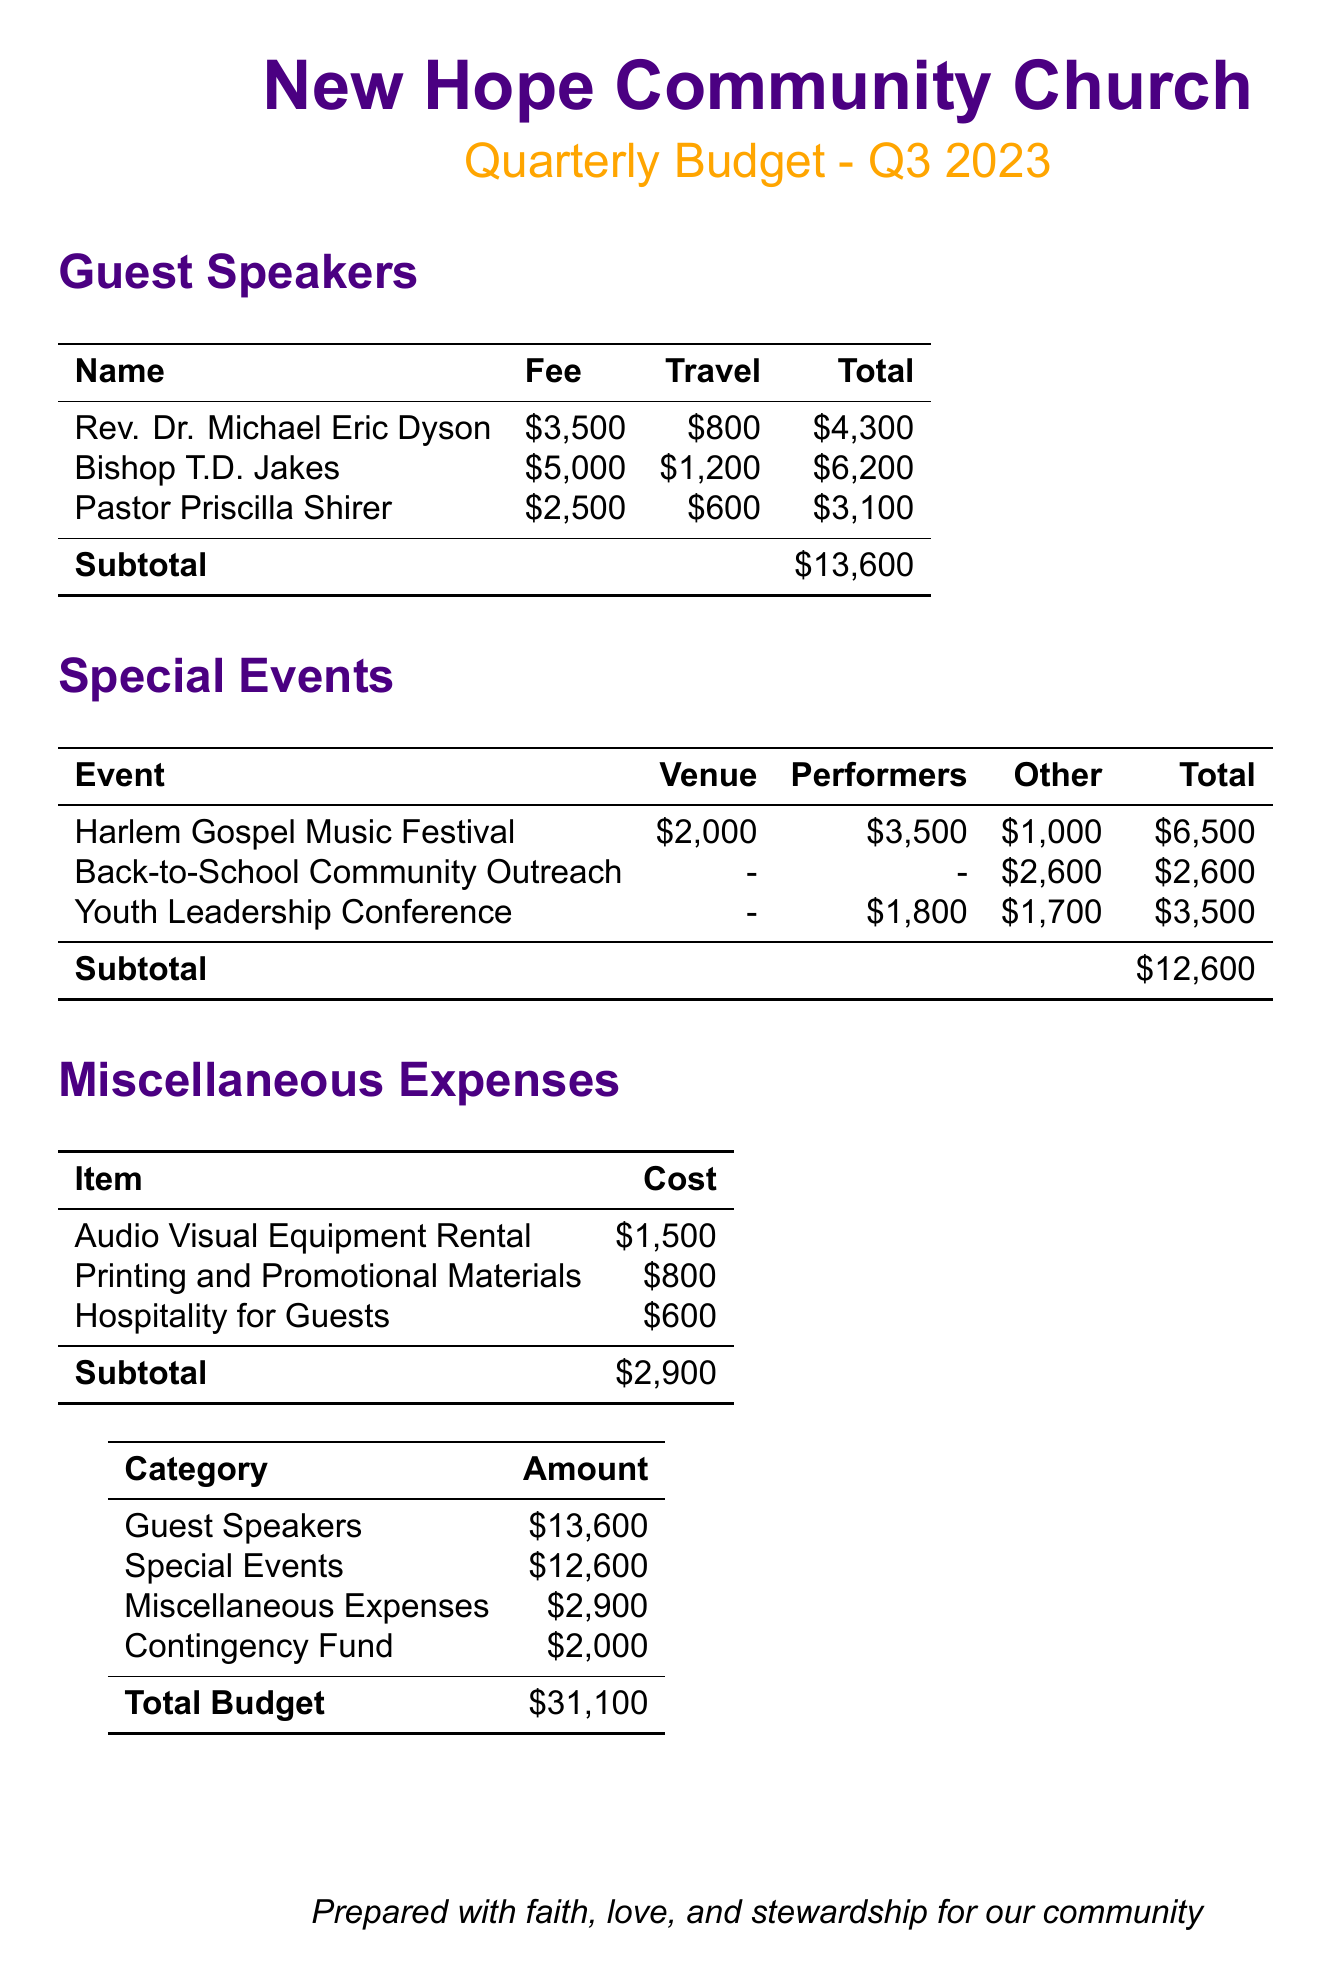What is the total cost for guest speakers? The total cost for guest speakers can be found in the budget section and is listed as $13,600.
Answer: $13,600 Who is the guest speaker with the highest fee? The guest speaker with the highest fee is listed as Bishop T.D. Jakes with a fee of $5,000.
Answer: Bishop T.D. Jakes What is the total amount allocated for special events? The total for special events is provided as $12,600 in the budget.
Answer: $12,600 How much is allocated for the contingency fund? The budget includes a line for the contingency fund which is set at $2,000.
Answer: $2,000 What are the miscellaneous expenses total? Total miscellaneous expenses are indicated as $2,900 in the budget document.
Answer: $2,900 Which event has the highest total cost? The event with the highest total cost is the Harlem Gospel Music Festival, totaling $6,500.
Answer: Harlem Gospel Music Festival What is the sum of all expenses listed? The document provides a total budget that reflects the sum of all expenses as $31,100.
Answer: $31,100 How much does the audio-visual equipment rental cost? The cost for audio-visual equipment rental is mentioned as $1,500 in the document.
Answer: $1,500 What is the total fee for Pastor Priscilla Shirer? The total fee for Pastor Priscilla Shirer, including travel, is shown as $3,100 in the document.
Answer: $3,100 